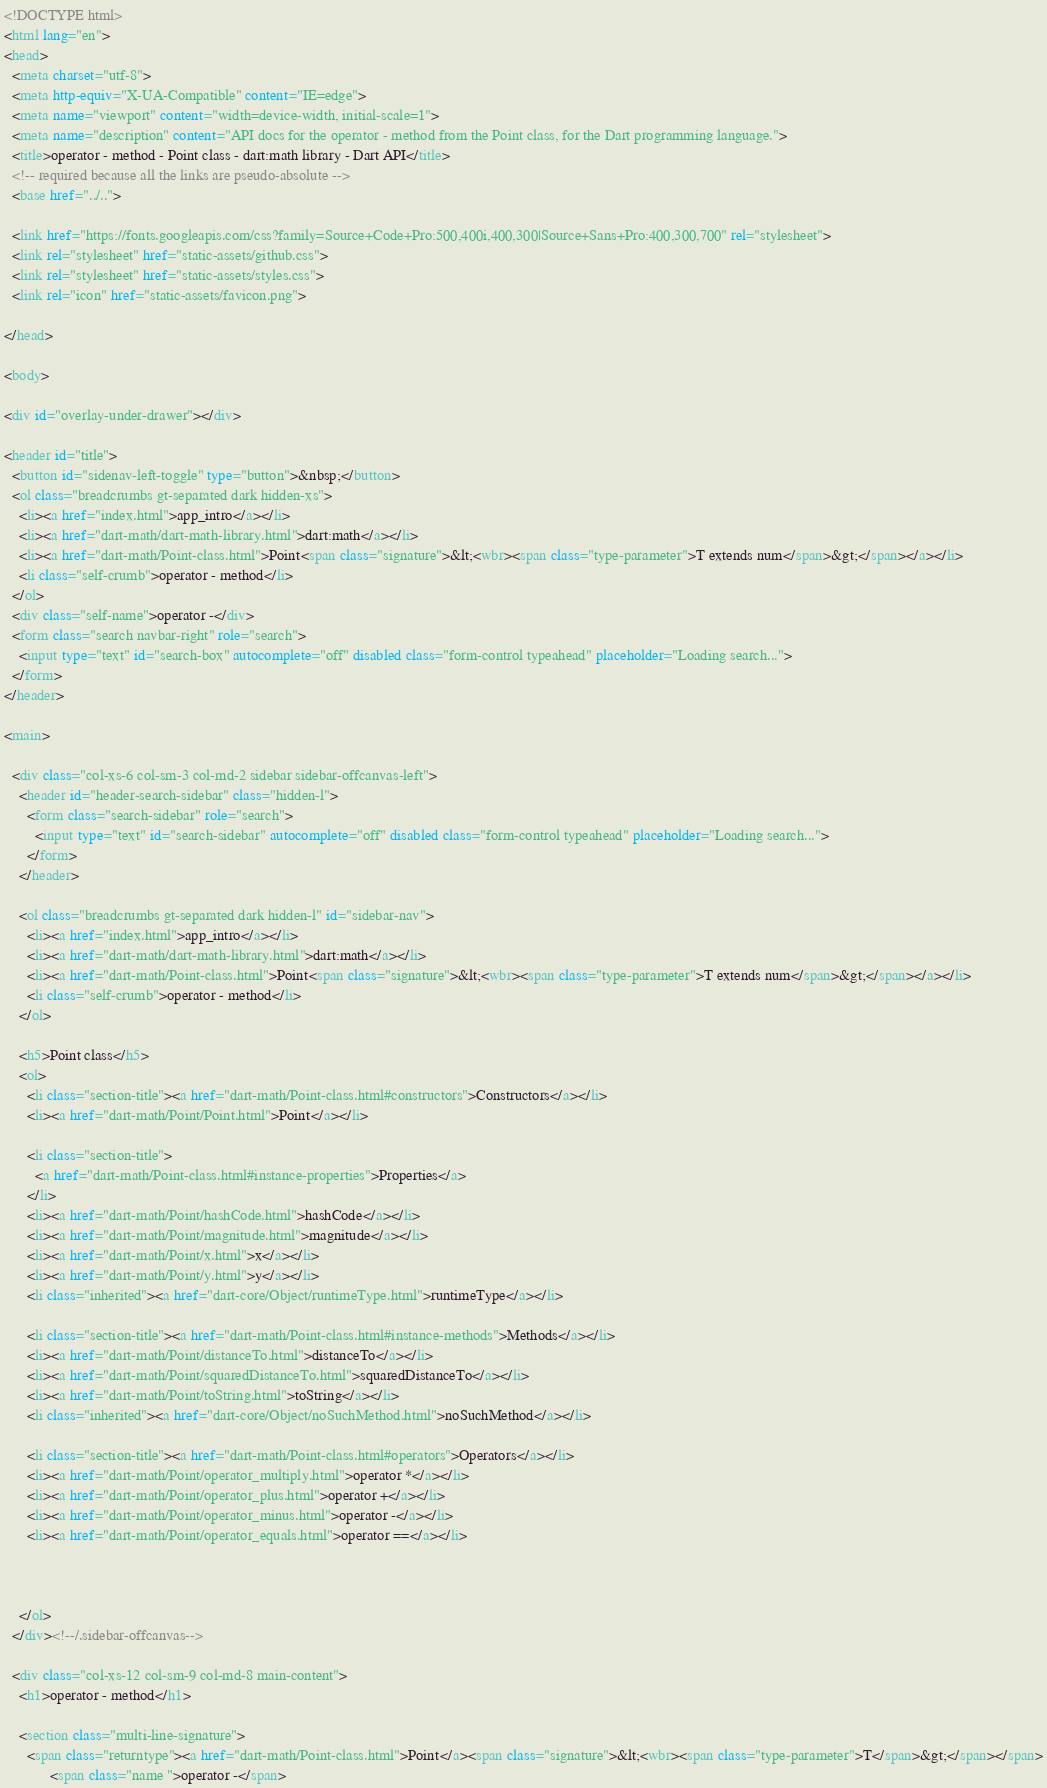Convert code to text. <code><loc_0><loc_0><loc_500><loc_500><_HTML_><!DOCTYPE html>
<html lang="en">
<head>
  <meta charset="utf-8">
  <meta http-equiv="X-UA-Compatible" content="IE=edge">
  <meta name="viewport" content="width=device-width, initial-scale=1">
  <meta name="description" content="API docs for the operator - method from the Point class, for the Dart programming language.">
  <title>operator - method - Point class - dart:math library - Dart API</title>
  <!-- required because all the links are pseudo-absolute -->
  <base href="../..">

  <link href="https://fonts.googleapis.com/css?family=Source+Code+Pro:500,400i,400,300|Source+Sans+Pro:400,300,700" rel="stylesheet">
  <link rel="stylesheet" href="static-assets/github.css">
  <link rel="stylesheet" href="static-assets/styles.css">
  <link rel="icon" href="static-assets/favicon.png">
  
</head>

<body>

<div id="overlay-under-drawer"></div>

<header id="title">
  <button id="sidenav-left-toggle" type="button">&nbsp;</button>
  <ol class="breadcrumbs gt-separated dark hidden-xs">
    <li><a href="index.html">app_intro</a></li>
    <li><a href="dart-math/dart-math-library.html">dart:math</a></li>
    <li><a href="dart-math/Point-class.html">Point<span class="signature">&lt;<wbr><span class="type-parameter">T extends num</span>&gt;</span></a></li>
    <li class="self-crumb">operator - method</li>
  </ol>
  <div class="self-name">operator -</div>
  <form class="search navbar-right" role="search">
    <input type="text" id="search-box" autocomplete="off" disabled class="form-control typeahead" placeholder="Loading search...">
  </form>
</header>

<main>

  <div class="col-xs-6 col-sm-3 col-md-2 sidebar sidebar-offcanvas-left">
    <header id="header-search-sidebar" class="hidden-l">
      <form class="search-sidebar" role="search">
        <input type="text" id="search-sidebar" autocomplete="off" disabled class="form-control typeahead" placeholder="Loading search...">
      </form>
    </header>
    
    <ol class="breadcrumbs gt-separated dark hidden-l" id="sidebar-nav">
      <li><a href="index.html">app_intro</a></li>
      <li><a href="dart-math/dart-math-library.html">dart:math</a></li>
      <li><a href="dart-math/Point-class.html">Point<span class="signature">&lt;<wbr><span class="type-parameter">T extends num</span>&gt;</span></a></li>
      <li class="self-crumb">operator - method</li>
    </ol>
    
    <h5>Point class</h5>
    <ol>
      <li class="section-title"><a href="dart-math/Point-class.html#constructors">Constructors</a></li>
      <li><a href="dart-math/Point/Point.html">Point</a></li>
    
      <li class="section-title">
        <a href="dart-math/Point-class.html#instance-properties">Properties</a>
      </li>
      <li><a href="dart-math/Point/hashCode.html">hashCode</a></li>
      <li><a href="dart-math/Point/magnitude.html">magnitude</a></li>
      <li><a href="dart-math/Point/x.html">x</a></li>
      <li><a href="dart-math/Point/y.html">y</a></li>
      <li class="inherited"><a href="dart-core/Object/runtimeType.html">runtimeType</a></li>
    
      <li class="section-title"><a href="dart-math/Point-class.html#instance-methods">Methods</a></li>
      <li><a href="dart-math/Point/distanceTo.html">distanceTo</a></li>
      <li><a href="dart-math/Point/squaredDistanceTo.html">squaredDistanceTo</a></li>
      <li><a href="dart-math/Point/toString.html">toString</a></li>
      <li class="inherited"><a href="dart-core/Object/noSuchMethod.html">noSuchMethod</a></li>
    
      <li class="section-title"><a href="dart-math/Point-class.html#operators">Operators</a></li>
      <li><a href="dart-math/Point/operator_multiply.html">operator *</a></li>
      <li><a href="dart-math/Point/operator_plus.html">operator +</a></li>
      <li><a href="dart-math/Point/operator_minus.html">operator -</a></li>
      <li><a href="dart-math/Point/operator_equals.html">operator ==</a></li>
    
    
    
    </ol>
  </div><!--/.sidebar-offcanvas-->

  <div class="col-xs-12 col-sm-9 col-md-8 main-content">
    <h1>operator - method</h1>

    <section class="multi-line-signature">
      <span class="returntype"><a href="dart-math/Point-class.html">Point</a><span class="signature">&lt;<wbr><span class="type-parameter">T</span>&gt;</span></span>
            <span class="name ">operator -</span></code> 